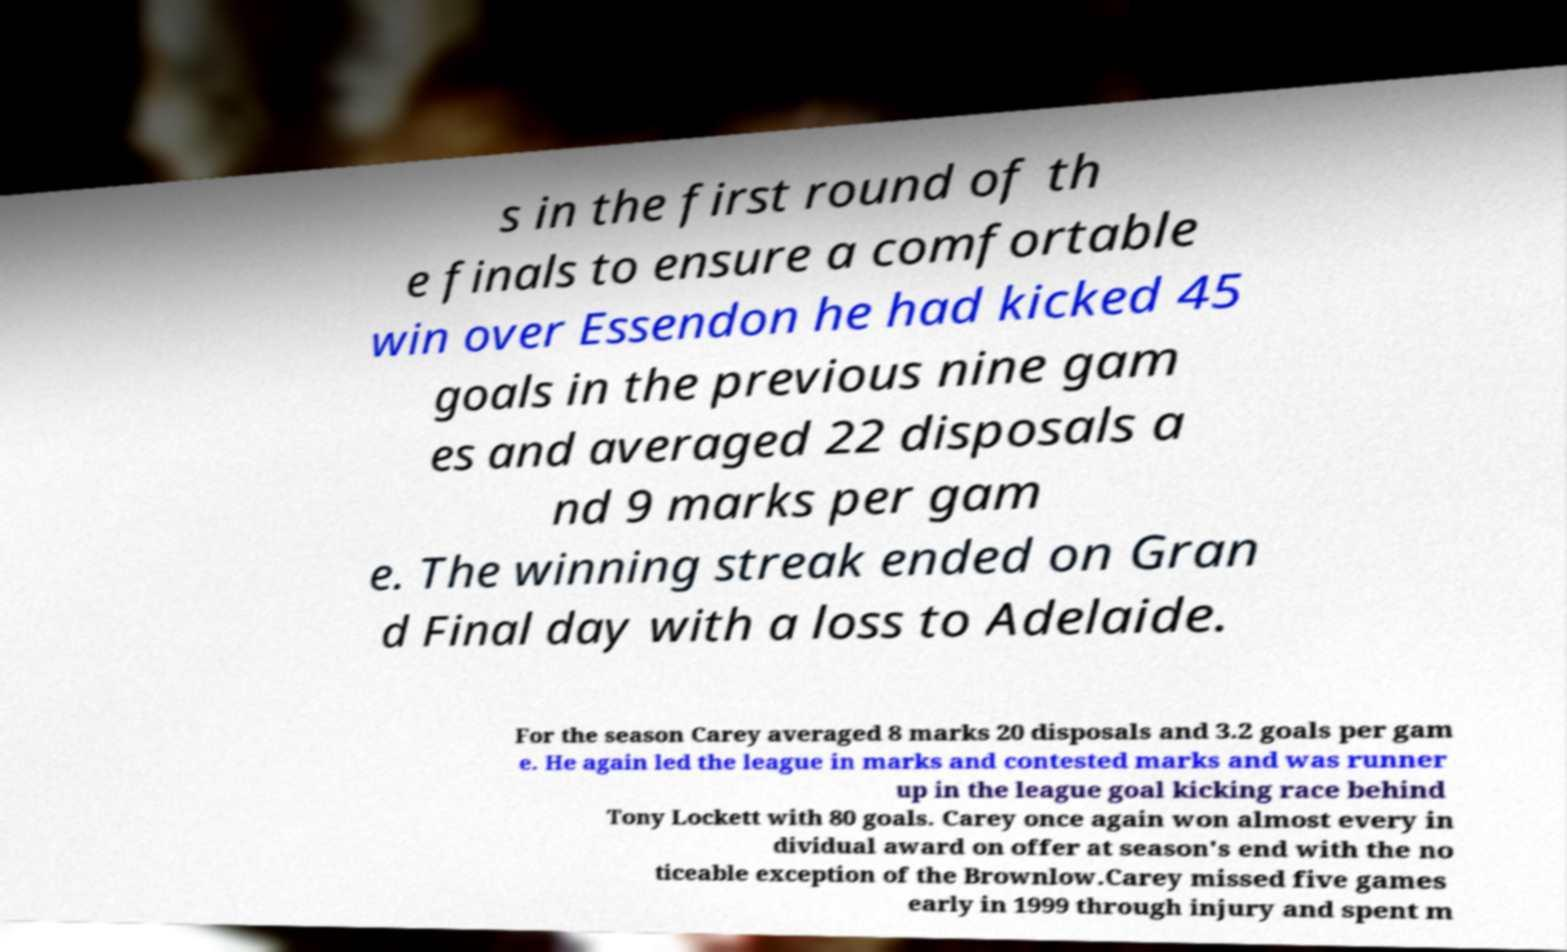Please read and relay the text visible in this image. What does it say? s in the first round of th e finals to ensure a comfortable win over Essendon he had kicked 45 goals in the previous nine gam es and averaged 22 disposals a nd 9 marks per gam e. The winning streak ended on Gran d Final day with a loss to Adelaide. For the season Carey averaged 8 marks 20 disposals and 3.2 goals per gam e. He again led the league in marks and contested marks and was runner up in the league goal kicking race behind Tony Lockett with 80 goals. Carey once again won almost every in dividual award on offer at season's end with the no ticeable exception of the Brownlow.Carey missed five games early in 1999 through injury and spent m 